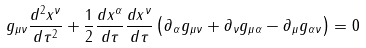<formula> <loc_0><loc_0><loc_500><loc_500>g _ { \mu \nu } { \frac { d ^ { 2 } x ^ { \nu } } { d \tau ^ { 2 } } } + { \frac { 1 } { 2 } } { \frac { d x ^ { \alpha } } { d \tau } } { \frac { d x ^ { \nu } } { d \tau } } \left ( \partial _ { \alpha } g _ { \mu \nu } + \partial _ { \nu } g _ { \mu \alpha } - \partial _ { \mu } g _ { \alpha \nu } \right ) = 0</formula> 